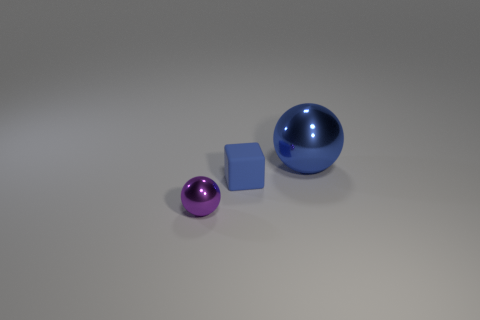What color is the matte thing that is the same size as the purple shiny ball?
Ensure brevity in your answer.  Blue. How many other objects are the same shape as the blue rubber thing?
Give a very brief answer. 0. There is a blue metal thing; is its size the same as the blue thing that is left of the blue metallic object?
Offer a terse response. No. What number of objects are either small balls or tiny gray metal things?
Offer a very short reply. 1. How many other things are the same size as the rubber cube?
Make the answer very short. 1. Is the color of the small metallic object the same as the object behind the rubber object?
Ensure brevity in your answer.  No. How many cylinders are either big cyan shiny things or small purple things?
Provide a succinct answer. 0. Are there any other things of the same color as the large metal object?
Make the answer very short. Yes. What is the material of the tiny object that is behind the metallic thing that is in front of the blue sphere?
Your response must be concise. Rubber. Is the purple object made of the same material as the blue thing that is in front of the large blue metallic object?
Give a very brief answer. No. 